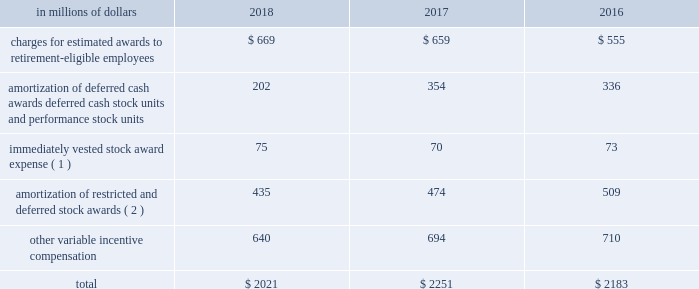Incentive compensation cost the table shows components of compensation expense , relating to certain of the incentive compensation programs described above : in a0millions a0of a0dollars 2018 2017 2016 charges for estimated awards to retirement-eligible employees $ 669 $ 659 $ 555 amortization of deferred cash awards , deferred cash stock units and performance stock units 202 354 336 immediately vested stock award expense ( 1 ) 75 70 73 amortization of restricted and deferred stock awards ( 2 ) 435 474 509 .
( 1 ) represents expense for immediately vested stock awards that generally were stock payments in lieu of cash compensation .
The expense is generally accrued as cash incentive compensation in the year prior to grant .
( 2 ) all periods include amortization expense for all unvested awards to non-retirement-eligible employees. .
What percentage of total compensation expense in 2018 is composed of other variable incentive compensation? 
Computations: (640 / 2021)
Answer: 0.31667. Incentive compensation cost the table shows components of compensation expense , relating to certain of the incentive compensation programs described above : in a0millions a0of a0dollars 2018 2017 2016 charges for estimated awards to retirement-eligible employees $ 669 $ 659 $ 555 amortization of deferred cash awards , deferred cash stock units and performance stock units 202 354 336 immediately vested stock award expense ( 1 ) 75 70 73 amortization of restricted and deferred stock awards ( 2 ) 435 474 509 .
( 1 ) represents expense for immediately vested stock awards that generally were stock payments in lieu of cash compensation .
The expense is generally accrued as cash incentive compensation in the year prior to grant .
( 2 ) all periods include amortization expense for all unvested awards to non-retirement-eligible employees. .
In 2018 what was the percent of the incentive compensation associated with charges for estimated awards to retirement-eligible employees? 
Rationale: in 2018 the incentive compensation associated with charges for estimated awards to retirement-eligible employees was 33.1%
Computations: (669 / 2021)
Answer: 0.33102. 